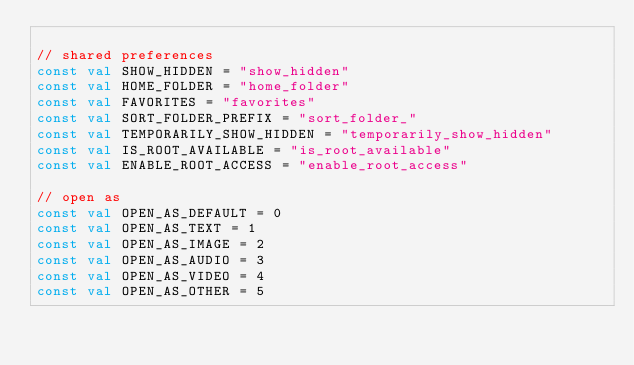Convert code to text. <code><loc_0><loc_0><loc_500><loc_500><_Kotlin_>
// shared preferences
const val SHOW_HIDDEN = "show_hidden"
const val HOME_FOLDER = "home_folder"
const val FAVORITES = "favorites"
const val SORT_FOLDER_PREFIX = "sort_folder_"
const val TEMPORARILY_SHOW_HIDDEN = "temporarily_show_hidden"
const val IS_ROOT_AVAILABLE = "is_root_available"
const val ENABLE_ROOT_ACCESS = "enable_root_access"

// open as
const val OPEN_AS_DEFAULT = 0
const val OPEN_AS_TEXT = 1
const val OPEN_AS_IMAGE = 2
const val OPEN_AS_AUDIO = 3
const val OPEN_AS_VIDEO = 4
const val OPEN_AS_OTHER = 5
</code> 